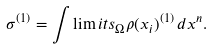Convert formula to latex. <formula><loc_0><loc_0><loc_500><loc_500>\sigma ^ { ( 1 ) } = \int \lim i t s _ { \Omega } \rho ( x _ { i } ) ^ { ( 1 ) } \, d x ^ { n } .</formula> 